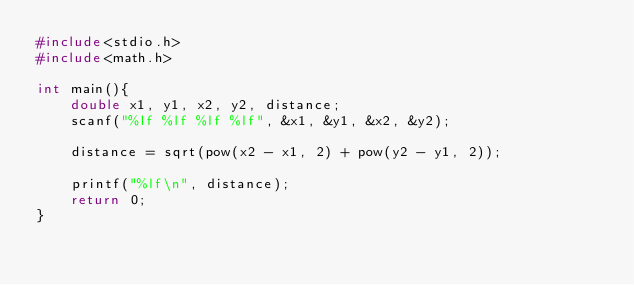Convert code to text. <code><loc_0><loc_0><loc_500><loc_500><_C_>#include<stdio.h>
#include<math.h>

int main(){
    double x1, y1, x2, y2, distance;
    scanf("%lf %lf %lf %lf", &x1, &y1, &x2, &y2);

    distance = sqrt(pow(x2 - x1, 2) + pow(y2 - y1, 2));

    printf("%lf\n", distance);
    return 0;
}
</code> 